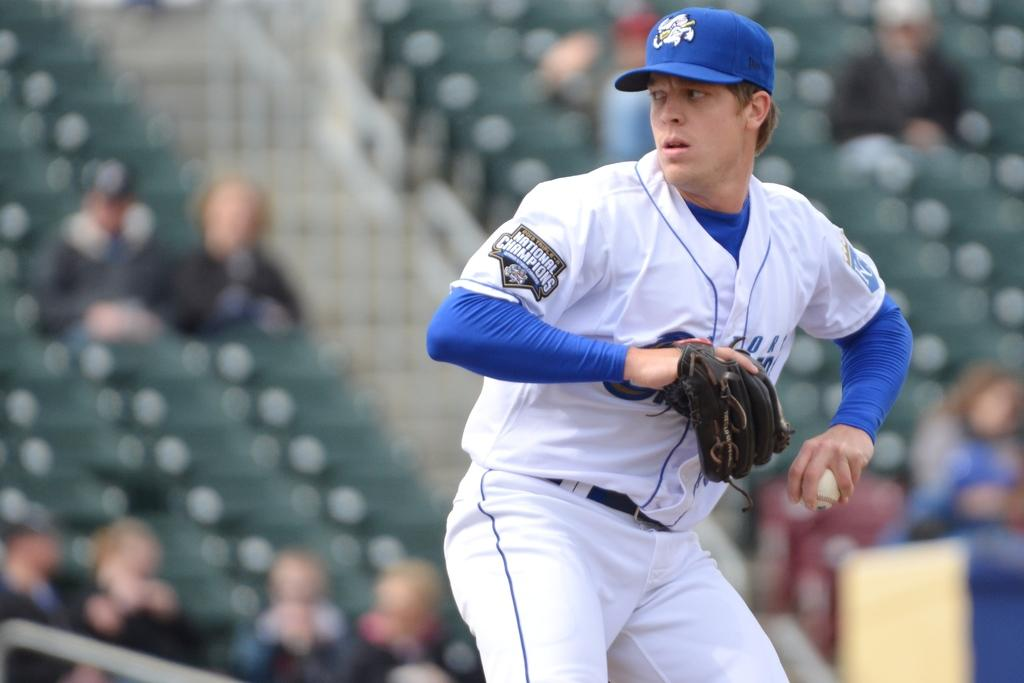<image>
Present a compact description of the photo's key features. The baseball player about to throw the ball is from a team that is the national champions. 